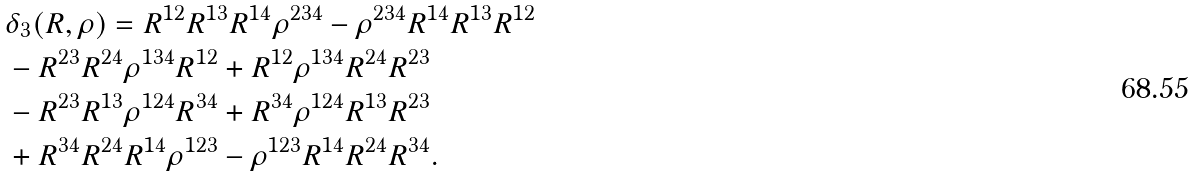Convert formula to latex. <formula><loc_0><loc_0><loc_500><loc_500>& \delta _ { 3 } ( R , \rho ) = R ^ { 1 2 } R ^ { 1 3 } R ^ { 1 4 } \rho ^ { 2 3 4 } - \rho ^ { 2 3 4 } R ^ { 1 4 } R ^ { 1 3 } R ^ { 1 2 } \\ & - R ^ { 2 3 } R ^ { 2 4 } \rho ^ { 1 3 4 } R ^ { 1 2 } + R ^ { 1 2 } \rho ^ { 1 3 4 } R ^ { 2 4 } R ^ { 2 3 } \\ & - R ^ { 2 3 } R ^ { 1 3 } \rho ^ { 1 2 4 } R ^ { 3 4 } + R ^ { 3 4 } \rho ^ { 1 2 4 } R ^ { 1 3 } R ^ { 2 3 } \\ & + R ^ { 3 4 } R ^ { 2 4 } R ^ { 1 4 } \rho ^ { 1 2 3 } - \rho ^ { 1 2 3 } R ^ { 1 4 } R ^ { 2 4 } R ^ { 3 4 } .</formula> 